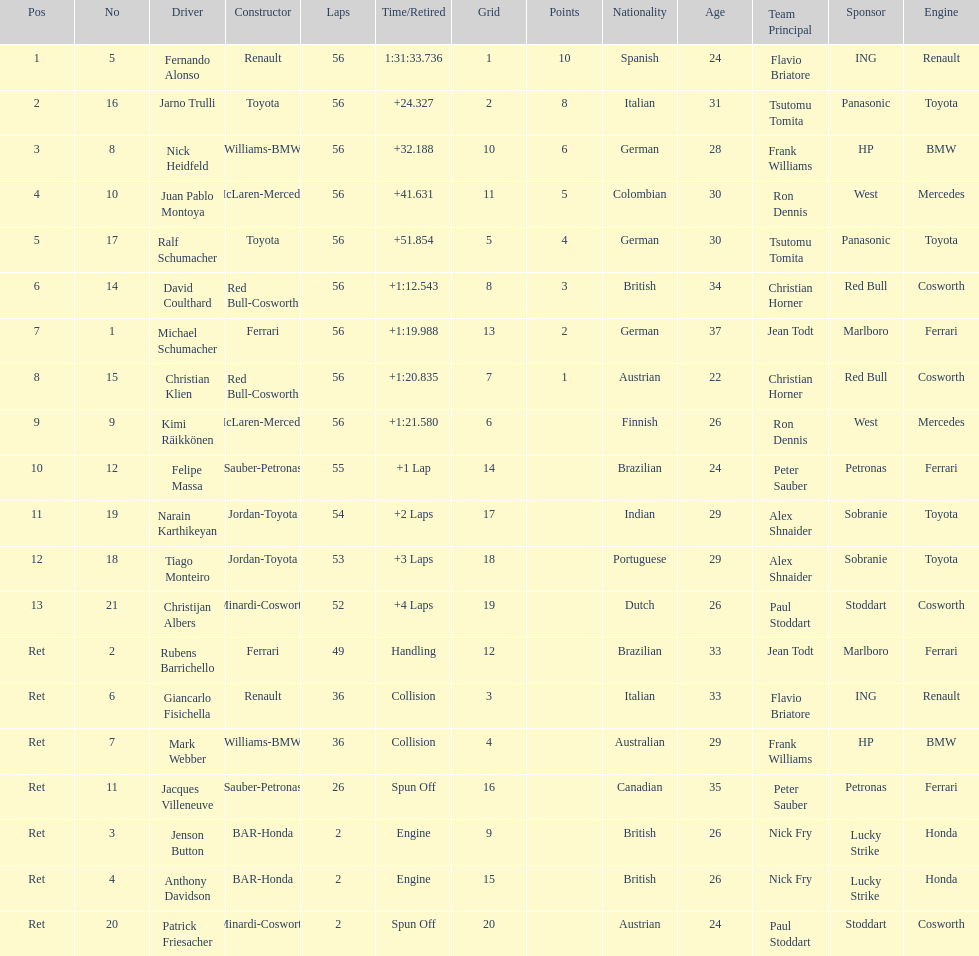Can you parse all the data within this table? {'header': ['Pos', 'No', 'Driver', 'Constructor', 'Laps', 'Time/Retired', 'Grid', 'Points', 'Nationality', 'Age', 'Team Principal', 'Sponsor', 'Engine'], 'rows': [['1', '5', 'Fernando Alonso', 'Renault', '56', '1:31:33.736', '1', '10', 'Spanish', '24', 'Flavio Briatore', 'ING', 'Renault'], ['2', '16', 'Jarno Trulli', 'Toyota', '56', '+24.327', '2', '8', 'Italian', '31', 'Tsutomu Tomita', 'Panasonic', 'Toyota'], ['3', '8', 'Nick Heidfeld', 'Williams-BMW', '56', '+32.188', '10', '6', 'German', '28', 'Frank Williams', 'HP', 'BMW'], ['4', '10', 'Juan Pablo Montoya', 'McLaren-Mercedes', '56', '+41.631', '11', '5', 'Colombian', '30', 'Ron Dennis', 'West', 'Mercedes'], ['5', '17', 'Ralf Schumacher', 'Toyota', '56', '+51.854', '5', '4', 'German', '30', 'Tsutomu Tomita', 'Panasonic', 'Toyota'], ['6', '14', 'David Coulthard', 'Red Bull-Cosworth', '56', '+1:12.543', '8', '3', 'British', '34', 'Christian Horner', 'Red Bull', 'Cosworth'], ['7', '1', 'Michael Schumacher', 'Ferrari', '56', '+1:19.988', '13', '2', 'German', '37', 'Jean Todt', 'Marlboro', 'Ferrari'], ['8', '15', 'Christian Klien', 'Red Bull-Cosworth', '56', '+1:20.835', '7', '1', 'Austrian', '22', 'Christian Horner', 'Red Bull', 'Cosworth'], ['9', '9', 'Kimi Räikkönen', 'McLaren-Mercedes', '56', '+1:21.580', '6', '', 'Finnish', '26', 'Ron Dennis', 'West', 'Mercedes'], ['10', '12', 'Felipe Massa', 'Sauber-Petronas', '55', '+1 Lap', '14', '', 'Brazilian', '24', 'Peter Sauber', 'Petronas', 'Ferrari'], ['11', '19', 'Narain Karthikeyan', 'Jordan-Toyota', '54', '+2 Laps', '17', '', 'Indian', '29', 'Alex Shnaider', 'Sobranie', 'Toyota'], ['12', '18', 'Tiago Monteiro', 'Jordan-Toyota', '53', '+3 Laps', '18', '', 'Portuguese', '29', 'Alex Shnaider', 'Sobranie', 'Toyota'], ['13', '21', 'Christijan Albers', 'Minardi-Cosworth', '52', '+4 Laps', '19', '', 'Dutch', '26', 'Paul Stoddart', 'Stoddart', 'Cosworth'], ['Ret', '2', 'Rubens Barrichello', 'Ferrari', '49', 'Handling', '12', '', 'Brazilian', '33', 'Jean Todt', 'Marlboro', 'Ferrari'], ['Ret', '6', 'Giancarlo Fisichella', 'Renault', '36', 'Collision', '3', '', 'Italian', '33', 'Flavio Briatore', 'ING', 'Renault'], ['Ret', '7', 'Mark Webber', 'Williams-BMW', '36', 'Collision', '4', '', 'Australian', '29', 'Frank Williams', 'HP', 'BMW'], ['Ret', '11', 'Jacques Villeneuve', 'Sauber-Petronas', '26', 'Spun Off', '16', '', 'Canadian', '35', 'Peter Sauber', 'Petronas', 'Ferrari'], ['Ret', '3', 'Jenson Button', 'BAR-Honda', '2', 'Engine', '9', '', 'British', '26', 'Nick Fry', 'Lucky Strike', 'Honda'], ['Ret', '4', 'Anthony Davidson', 'BAR-Honda', '2', 'Engine', '15', '', 'British', '26', 'Nick Fry', 'Lucky Strike', 'Honda'], ['Ret', '20', 'Patrick Friesacher', 'Minardi-Cosworth', '2', 'Spun Off', '20', '', 'Austrian', '24', 'Paul Stoddart', 'Stoddart', 'Cosworth']]} How many germans finished in the top five? 2. 